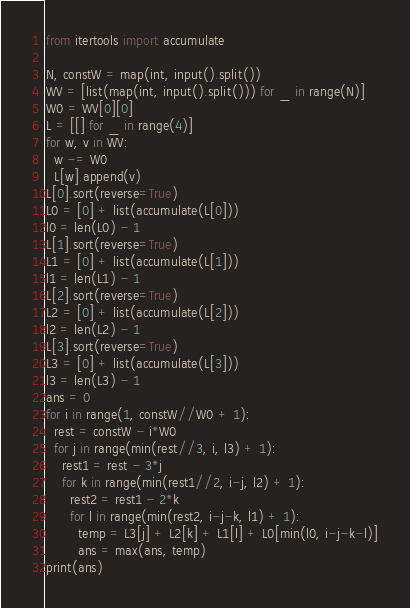Convert code to text. <code><loc_0><loc_0><loc_500><loc_500><_Python_>from itertools import accumulate

N, constW = map(int, input().split())
WV = [list(map(int, input().split())) for _ in range(N)]
W0 = WV[0][0]
L = [[] for _ in range(4)]
for w, v in WV:
  w -= W0
  L[w].append(v)
L[0].sort(reverse=True)
L0 = [0] + list(accumulate(L[0]))
l0 = len(L0) - 1
L[1].sort(reverse=True)
L1 = [0] + list(accumulate(L[1]))
l1 = len(L1) - 1
L[2].sort(reverse=True)
L2 = [0] + list(accumulate(L[2]))
l2 = len(L2) - 1
L[3].sort(reverse=True)
L3 = [0] + list(accumulate(L[3]))
l3 = len(L3) - 1
ans = 0
for i in range(1, constW//W0 + 1):
  rest = constW - i*W0
  for j in range(min(rest//3, i, l3) + 1):
    rest1 = rest - 3*j
    for k in range(min(rest1//2, i-j, l2) + 1):
      rest2 = rest1 - 2*k
      for l in range(min(rest2, i-j-k, l1) + 1):
        temp = L3[j] + L2[k] + L1[l] + L0[min(l0, i-j-k-l)]
        ans = max(ans, temp)
print(ans)</code> 